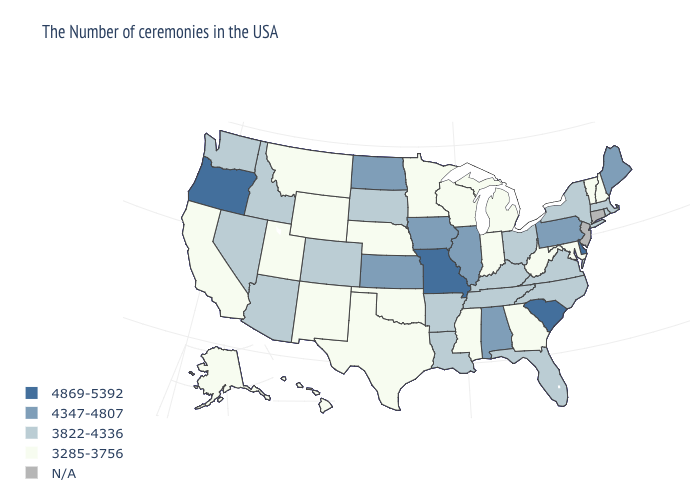Does West Virginia have the lowest value in the South?
Answer briefly. Yes. Which states have the highest value in the USA?
Short answer required. Delaware, South Carolina, Missouri, Oregon. What is the lowest value in states that border Kansas?
Answer briefly. 3285-3756. Is the legend a continuous bar?
Short answer required. No. What is the highest value in states that border Arkansas?
Concise answer only. 4869-5392. What is the value of Oklahoma?
Write a very short answer. 3285-3756. What is the lowest value in the USA?
Keep it brief. 3285-3756. Name the states that have a value in the range 4347-4807?
Give a very brief answer. Maine, Pennsylvania, Alabama, Illinois, Iowa, Kansas, North Dakota. What is the value of Michigan?
Write a very short answer. 3285-3756. Name the states that have a value in the range 3285-3756?
Short answer required. New Hampshire, Vermont, Maryland, West Virginia, Georgia, Michigan, Indiana, Wisconsin, Mississippi, Minnesota, Nebraska, Oklahoma, Texas, Wyoming, New Mexico, Utah, Montana, California, Alaska, Hawaii. Which states have the highest value in the USA?
Answer briefly. Delaware, South Carolina, Missouri, Oregon. Is the legend a continuous bar?
Give a very brief answer. No. What is the highest value in states that border Rhode Island?
Concise answer only. 3822-4336. 